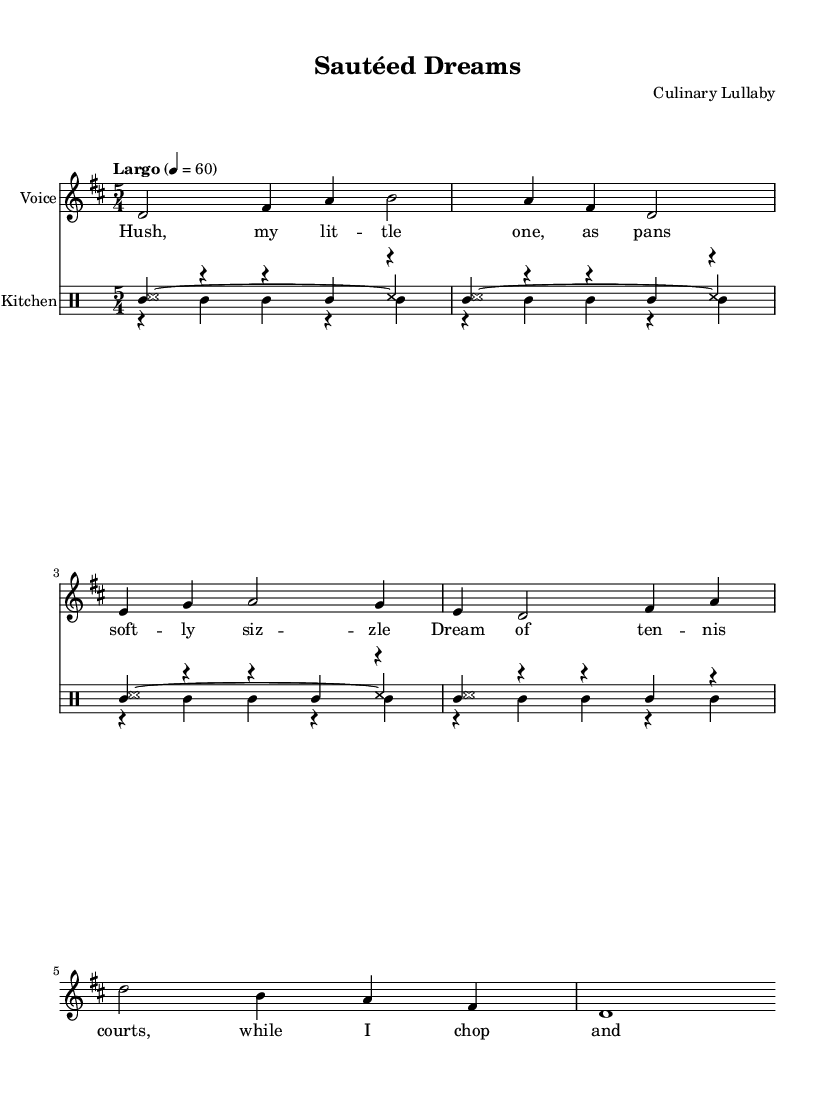What is the key signature of this music? The key signature indicates that this music is in D major, as shown by the two sharp symbols (F# and C#) on the staff.
Answer: D major What is the time signature of this piece? The time signature is located at the beginning of the music and shows "5/4," which means there are five beats in each measure and the quarter note gets the beat.
Answer: 5/4 What is the tempo marking for this piece? The tempo marking in the score shows "Largo" with a metronome marking of quarter note equals 60, indicating a slow tempo.
Answer: Largo What is the primary theme of the lyrics? The lyrics express a soothing message for a child, incorporating imagery related to cooking, specifically the soft sizzle of pans and chopping.
Answer: Soothe How many different percussion instruments are used in the score? The score includes three different percussion rhythms: one for the general kitchen sounds, one for knife chopping, and one for the sizzling, all represented by separate drum voices.
Answer: Three How does the structure of the piece reflect its experimental nature? The piece combines traditional lullaby elements with unconventional drum sounds from kitchen utensils, creating a unique blend of melody and rhythm that reflects the chaotic nature of preparing food while soothing a child.
Answer: Unique blend What rhythmic pattern is prominent in the percussion section? The percussion section prominently features a repeating rhythmic pattern that mimics food preparation sounds, notably the "wbh" which appears throughout the measures, providing a consistent rhythm.
Answer: Repeating pattern 